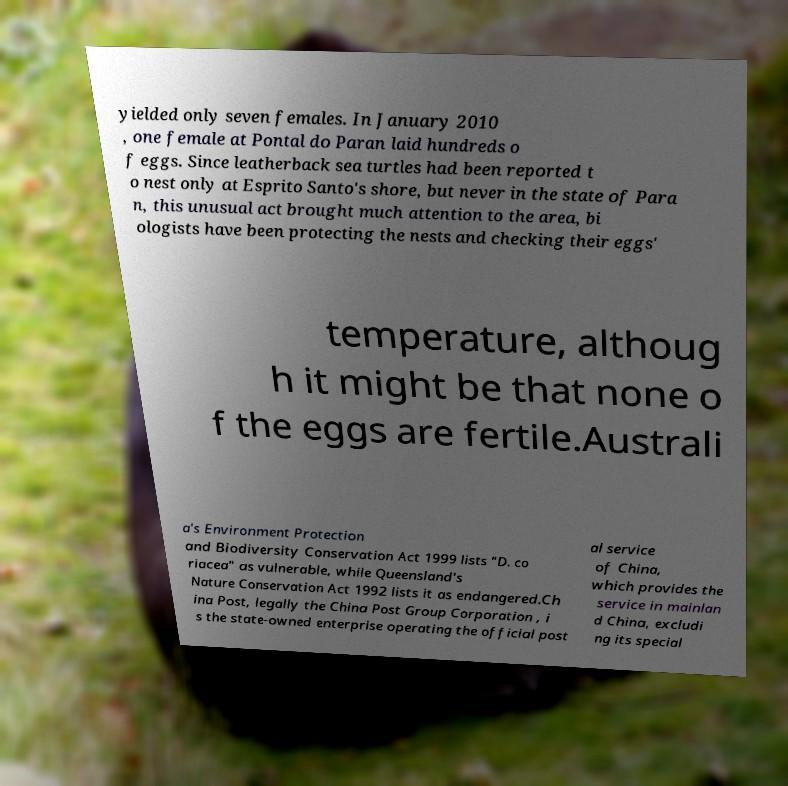For documentation purposes, I need the text within this image transcribed. Could you provide that? yielded only seven females. In January 2010 , one female at Pontal do Paran laid hundreds o f eggs. Since leatherback sea turtles had been reported t o nest only at Esprito Santo's shore, but never in the state of Para n, this unusual act brought much attention to the area, bi ologists have been protecting the nests and checking their eggs' temperature, althoug h it might be that none o f the eggs are fertile.Australi a's Environment Protection and Biodiversity Conservation Act 1999 lists "D. co riacea" as vulnerable, while Queensland's Nature Conservation Act 1992 lists it as endangered.Ch ina Post, legally the China Post Group Corporation , i s the state-owned enterprise operating the official post al service of China, which provides the service in mainlan d China, excludi ng its special 